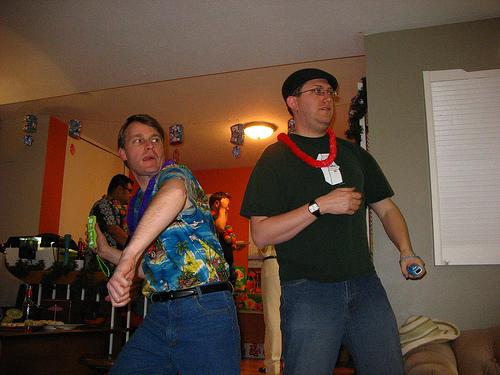What are the two men doing and what gaming console are they using in the image? Two men are playing video games using the Nintendo Wii console. Identify two contrasting colors present in the different shirts in the image. Colorful (Hawaiian print) and black. What type of hat is on the arm of the sofa and what color is it? A striped hat with a brim sits on the arm of the sofa. What is the key activity happening at this party, and what is the prominent theme? Playing video games is the key activity, and the theme is Hawaiian. Name some accessories worn by the man with the Hawaiian print shirt. Wire rim glasses and red plastic lei. Tell me about the background of where the people are gathered to play video games. A house party with Hawaiian-themed decorations and red walls. Mention two things that depict the theme of the Hawaiian party in the picture. Man wearing floral Hawaiian shirt and red plastic lei. Provide a brief description of the scene in the image. Two men at a Hawaiian themed house party playing video games using Nintendo Wii controllers while others enjoy the event. Identify the colors of the shirt, jeans, and necklace of the people. Colorful Hawaiian shirt, blue jeans, and red necklace. Briefly describe the lighting situation in the room where the party is taking place. The light is turned on, and there's a ceiling light fixture. Look for a cat sitting on the windowsill and describe its color. No, it's not mentioned in the image. 